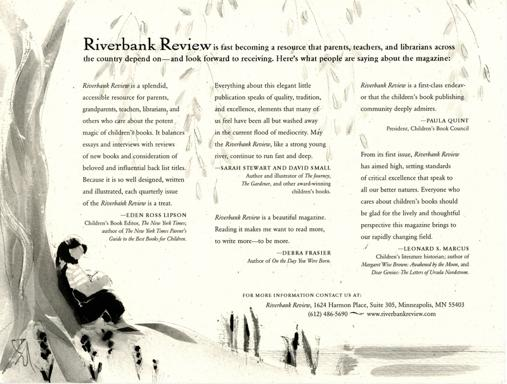What do people appreciate about the Riverbank Review? Readers and educators alike treasure the Riverbank Review for its discerning approach to children's literature, encompassing its artful layout, the thoroughness of its book reviews, and its insightful commentary on literary trends and classics. The magazine's enriching content serves as a bridge connecting the wisdom found within the pages of children's books to the crucial role these narratives play in shaping young minds—much as the serene illustration in this image invites contemplation and imaginative thought. 